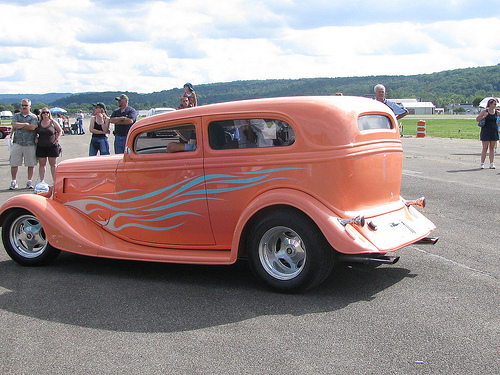<image>
Can you confirm if the flame is on the car? Yes. Looking at the image, I can see the flame is positioned on top of the car, with the car providing support. Is the car behind the woman? No. The car is not behind the woman. From this viewpoint, the car appears to be positioned elsewhere in the scene. 